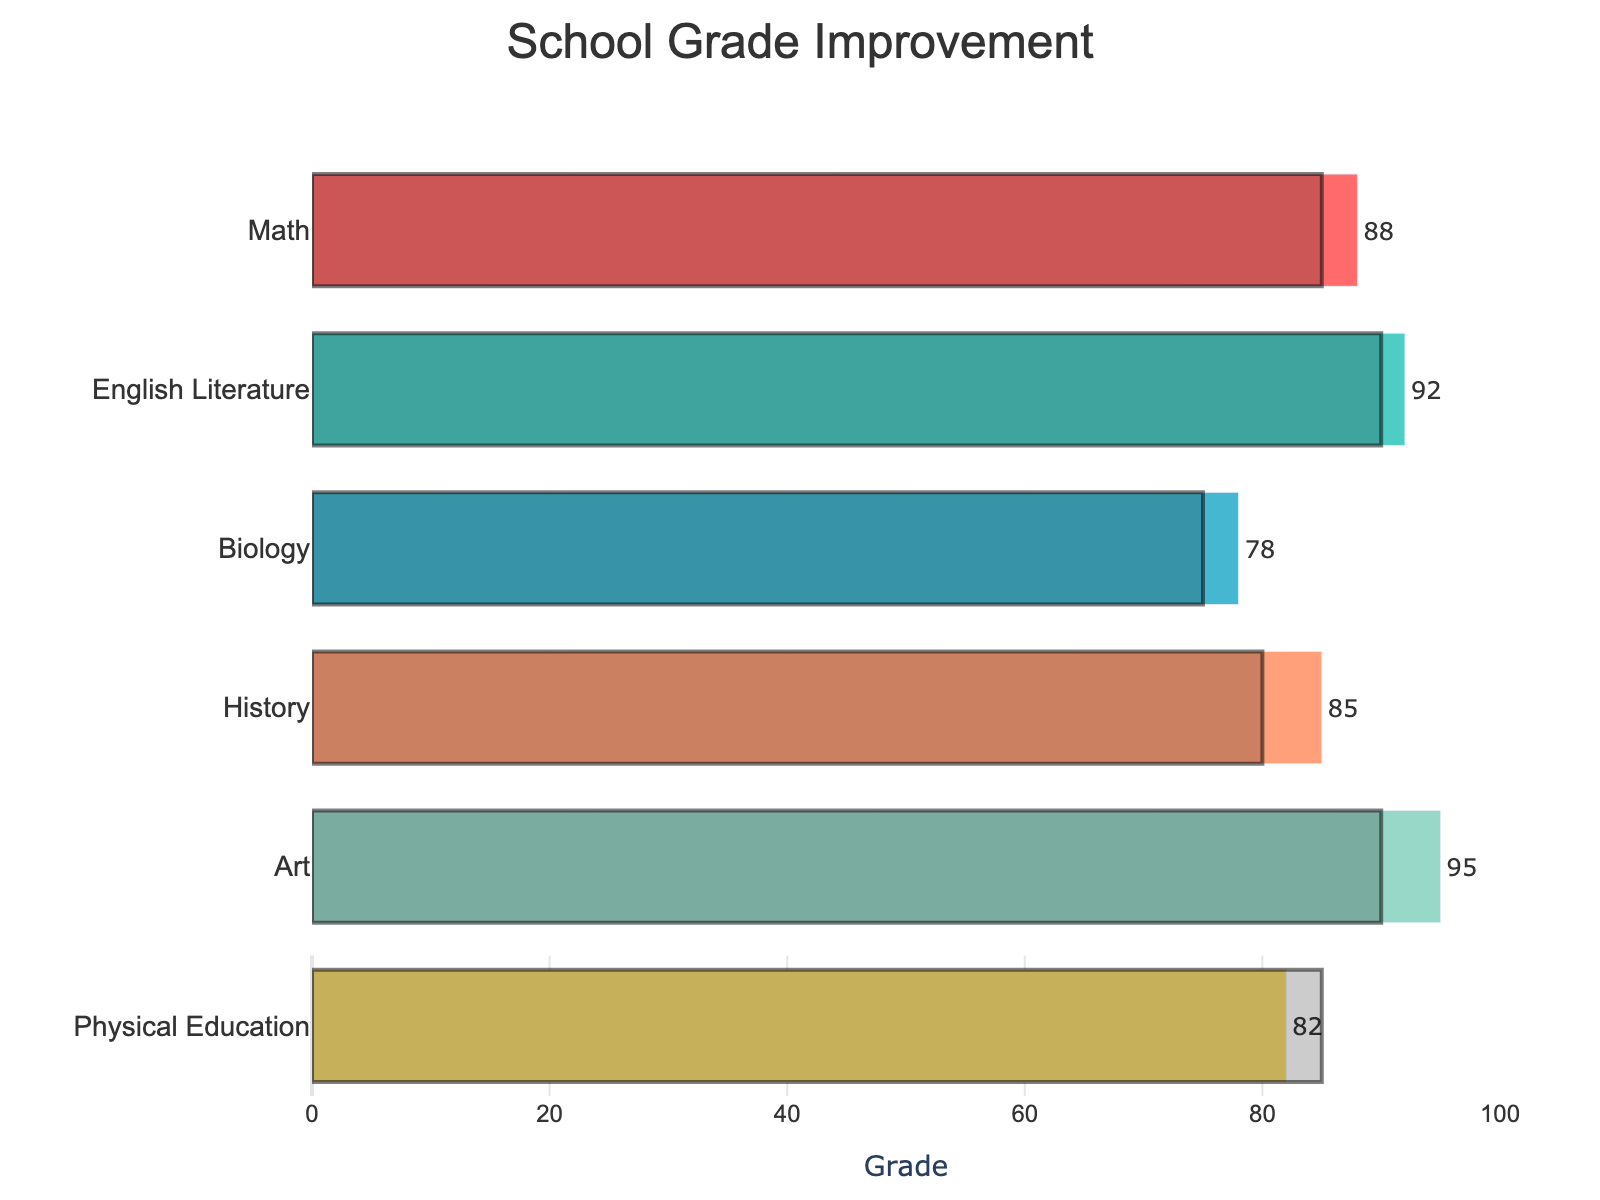What is the highest current grade achieved in any subject? The highest current grade is the maximum value of the "Current Grade" bars. Looking at the figure, Art has a current grade of 95, which is the highest.
Answer: 95 Which subject has the lowest current grade? To find the lowest current grade, we need to identify the bar with the smallest value in the "Current Grade" section of the chart. Biology has a current grade of 78, which is the lowest.
Answer: Biology What is the difference between the current grade and the previous goal in Math? To find the difference, subtract the previous goal from the current grade in Math: 88 (current grade) - 85 (previous goal). The difference is 3.
Answer: 3 Does any subject meet or exceed its maximum grade? Check if any current grades are equal to or greater than the "Maximum Grade" values. None of the current grades reach the maximum grade of 100.
Answer: No How many subjects have a current grade higher than their previous goal? Compare the current grades with the previous goals for each subject. Math (88 > 85), English Literature (92 > 90), Biology (78 > 75), History (85 > 80), and Art (95 > 90) all have higher current grades compared to their previous goals. Physical Education is the only subject where the previous goal was higher. There are five subjects where the current grade is higher than the previous goal.
Answer: 5 In which subject is the gap between the current grade and the previous goal the smallest? Find the differences for each subject: Math (3), English Literature (2), Biology (3), History (5), Art (5), and Physical Education (-3). The smallest positive difference is 2, which occurs in English Literature.
Answer: English Literature How does the current grade in Physical Education compare to its previous goal? Check the values for Physical Education: the current grade is 82, and the previous goal is 85. The current grade is lower than the previous goal by 3 points.
Answer: Lower by 3 points What is the average of the current grades across all subjects? Sum all the current grades and divide by the number of subjects: (88 + 92 + 78 + 85 + 95 + 82) / 6 equals 86.67.
Answer: 86.67 Which subject shows the greatest improvement relative to the previous goal? Calculate the improvements for each subject as the difference between the current grade and the previous goal. Improvements are: Math (3), English Literature (2), Biology (3), History (5), Art (5), Physical Education (-3). The subjects Art and History show the greatest improvement by 5 points.
Answer: Art and History 